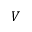<formula> <loc_0><loc_0><loc_500><loc_500>V</formula> 